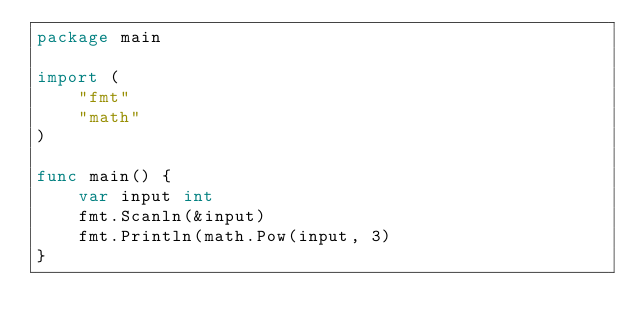Convert code to text. <code><loc_0><loc_0><loc_500><loc_500><_Go_>package main

import (
    "fmt"
    "math"
)

func main() {
    var input int
    fmt.Scanln(&input)
    fmt.Println(math.Pow(input, 3)
}
</code> 